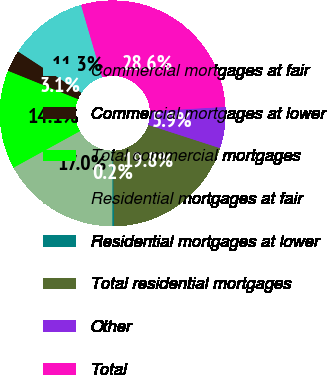Convert chart. <chart><loc_0><loc_0><loc_500><loc_500><pie_chart><fcel>Commercial mortgages at fair<fcel>Commercial mortgages at lower<fcel>Total commercial mortgages<fcel>Residential mortgages at fair<fcel>Residential mortgages at lower<fcel>Total residential mortgages<fcel>Other<fcel>Total<nl><fcel>11.29%<fcel>3.07%<fcel>14.13%<fcel>16.97%<fcel>0.23%<fcel>19.81%<fcel>5.9%<fcel>28.61%<nl></chart> 